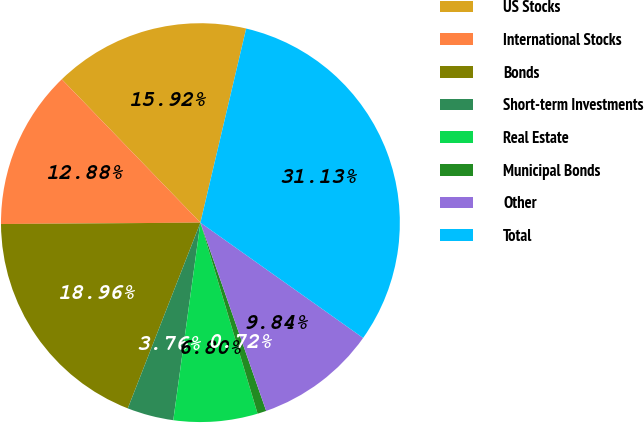Convert chart. <chart><loc_0><loc_0><loc_500><loc_500><pie_chart><fcel>US Stocks<fcel>International Stocks<fcel>Bonds<fcel>Short-term Investments<fcel>Real Estate<fcel>Municipal Bonds<fcel>Other<fcel>Total<nl><fcel>15.92%<fcel>12.88%<fcel>18.96%<fcel>3.76%<fcel>6.8%<fcel>0.72%<fcel>9.84%<fcel>31.13%<nl></chart> 